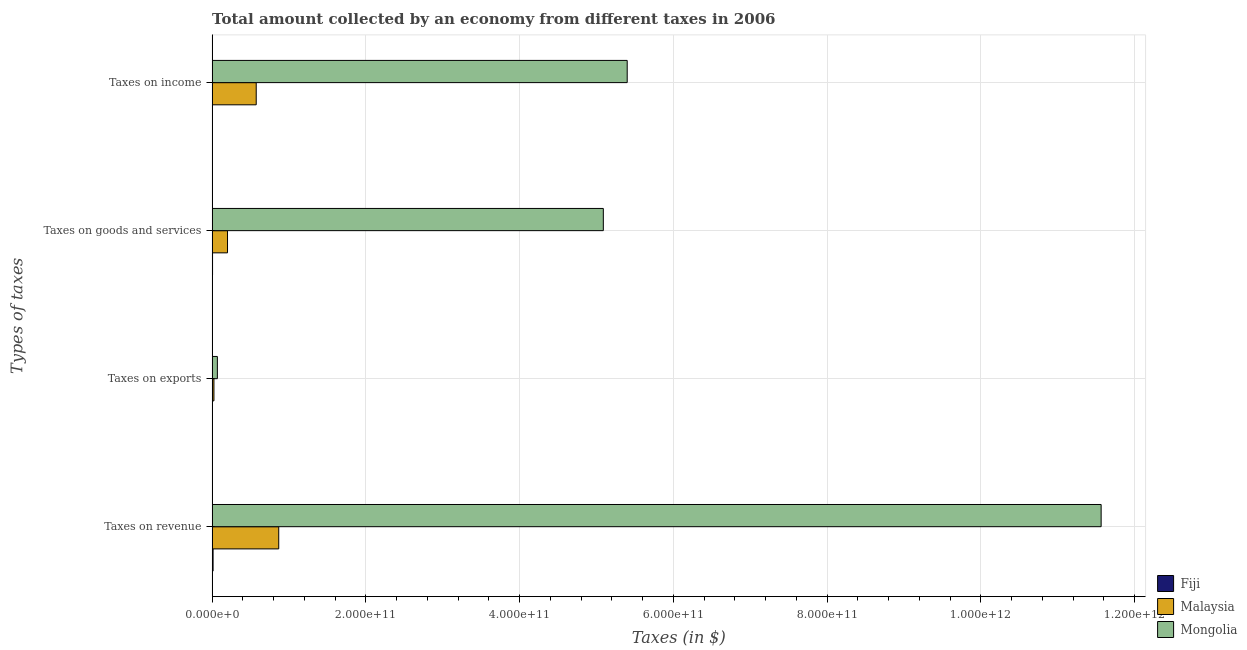How many different coloured bars are there?
Provide a succinct answer. 3. How many bars are there on the 3rd tick from the top?
Make the answer very short. 3. What is the label of the 4th group of bars from the top?
Make the answer very short. Taxes on revenue. What is the amount collected as tax on exports in Malaysia?
Give a very brief answer. 2.36e+09. Across all countries, what is the maximum amount collected as tax on income?
Make the answer very short. 5.40e+11. Across all countries, what is the minimum amount collected as tax on revenue?
Offer a very short reply. 1.25e+09. In which country was the amount collected as tax on exports maximum?
Keep it short and to the point. Mongolia. In which country was the amount collected as tax on income minimum?
Provide a short and direct response. Fiji. What is the total amount collected as tax on exports in the graph?
Your answer should be compact. 9.21e+09. What is the difference between the amount collected as tax on revenue in Mongolia and that in Malaysia?
Provide a short and direct response. 1.07e+12. What is the difference between the amount collected as tax on income in Malaysia and the amount collected as tax on revenue in Fiji?
Offer a very short reply. 5.61e+1. What is the average amount collected as tax on exports per country?
Your response must be concise. 3.07e+09. What is the difference between the amount collected as tax on revenue and amount collected as tax on goods in Malaysia?
Your answer should be very brief. 6.66e+1. In how many countries, is the amount collected as tax on exports greater than 280000000000 $?
Provide a succinct answer. 0. What is the ratio of the amount collected as tax on income in Malaysia to that in Mongolia?
Provide a succinct answer. 0.11. Is the difference between the amount collected as tax on revenue in Mongolia and Malaysia greater than the difference between the amount collected as tax on goods in Mongolia and Malaysia?
Your answer should be very brief. Yes. What is the difference between the highest and the second highest amount collected as tax on exports?
Provide a short and direct response. 4.48e+09. What is the difference between the highest and the lowest amount collected as tax on revenue?
Offer a terse response. 1.16e+12. In how many countries, is the amount collected as tax on income greater than the average amount collected as tax on income taken over all countries?
Offer a very short reply. 1. Is the sum of the amount collected as tax on income in Fiji and Mongolia greater than the maximum amount collected as tax on goods across all countries?
Ensure brevity in your answer.  Yes. Is it the case that in every country, the sum of the amount collected as tax on goods and amount collected as tax on income is greater than the sum of amount collected as tax on exports and amount collected as tax on revenue?
Ensure brevity in your answer.  No. What does the 3rd bar from the top in Taxes on income represents?
Make the answer very short. Fiji. What does the 3rd bar from the bottom in Taxes on goods and services represents?
Provide a succinct answer. Mongolia. Is it the case that in every country, the sum of the amount collected as tax on revenue and amount collected as tax on exports is greater than the amount collected as tax on goods?
Make the answer very short. Yes. How many bars are there?
Your response must be concise. 12. How many countries are there in the graph?
Offer a terse response. 3. What is the difference between two consecutive major ticks on the X-axis?
Offer a terse response. 2.00e+11. Are the values on the major ticks of X-axis written in scientific E-notation?
Ensure brevity in your answer.  Yes. Does the graph contain any zero values?
Provide a short and direct response. No. Does the graph contain grids?
Provide a short and direct response. Yes. What is the title of the graph?
Ensure brevity in your answer.  Total amount collected by an economy from different taxes in 2006. Does "Seychelles" appear as one of the legend labels in the graph?
Ensure brevity in your answer.  No. What is the label or title of the X-axis?
Offer a terse response. Taxes (in $). What is the label or title of the Y-axis?
Give a very brief answer. Types of taxes. What is the Taxes (in $) in Fiji in Taxes on revenue?
Make the answer very short. 1.25e+09. What is the Taxes (in $) in Malaysia in Taxes on revenue?
Make the answer very short. 8.66e+1. What is the Taxes (in $) in Mongolia in Taxes on revenue?
Offer a terse response. 1.16e+12. What is the Taxes (in $) in Fiji in Taxes on exports?
Your answer should be compact. 8.72e+06. What is the Taxes (in $) in Malaysia in Taxes on exports?
Your response must be concise. 2.36e+09. What is the Taxes (in $) of Mongolia in Taxes on exports?
Give a very brief answer. 6.84e+09. What is the Taxes (in $) of Fiji in Taxes on goods and services?
Make the answer very short. 5.62e+08. What is the Taxes (in $) of Malaysia in Taxes on goods and services?
Give a very brief answer. 2.00e+1. What is the Taxes (in $) in Mongolia in Taxes on goods and services?
Give a very brief answer. 5.09e+11. What is the Taxes (in $) of Fiji in Taxes on income?
Your response must be concise. 4.46e+08. What is the Taxes (in $) of Malaysia in Taxes on income?
Give a very brief answer. 5.73e+1. What is the Taxes (in $) of Mongolia in Taxes on income?
Your response must be concise. 5.40e+11. Across all Types of taxes, what is the maximum Taxes (in $) in Fiji?
Your answer should be very brief. 1.25e+09. Across all Types of taxes, what is the maximum Taxes (in $) of Malaysia?
Provide a short and direct response. 8.66e+1. Across all Types of taxes, what is the maximum Taxes (in $) of Mongolia?
Make the answer very short. 1.16e+12. Across all Types of taxes, what is the minimum Taxes (in $) in Fiji?
Your answer should be very brief. 8.72e+06. Across all Types of taxes, what is the minimum Taxes (in $) of Malaysia?
Your answer should be very brief. 2.36e+09. Across all Types of taxes, what is the minimum Taxes (in $) in Mongolia?
Offer a very short reply. 6.84e+09. What is the total Taxes (in $) of Fiji in the graph?
Provide a succinct answer. 2.26e+09. What is the total Taxes (in $) in Malaysia in the graph?
Your answer should be compact. 1.66e+11. What is the total Taxes (in $) of Mongolia in the graph?
Make the answer very short. 2.21e+12. What is the difference between the Taxes (in $) of Fiji in Taxes on revenue and that in Taxes on exports?
Make the answer very short. 1.24e+09. What is the difference between the Taxes (in $) of Malaysia in Taxes on revenue and that in Taxes on exports?
Offer a very short reply. 8.43e+1. What is the difference between the Taxes (in $) in Mongolia in Taxes on revenue and that in Taxes on exports?
Make the answer very short. 1.15e+12. What is the difference between the Taxes (in $) in Fiji in Taxes on revenue and that in Taxes on goods and services?
Make the answer very short. 6.84e+08. What is the difference between the Taxes (in $) in Malaysia in Taxes on revenue and that in Taxes on goods and services?
Provide a short and direct response. 6.66e+1. What is the difference between the Taxes (in $) in Mongolia in Taxes on revenue and that in Taxes on goods and services?
Provide a succinct answer. 6.47e+11. What is the difference between the Taxes (in $) of Fiji in Taxes on revenue and that in Taxes on income?
Provide a succinct answer. 7.99e+08. What is the difference between the Taxes (in $) of Malaysia in Taxes on revenue and that in Taxes on income?
Your answer should be compact. 2.93e+1. What is the difference between the Taxes (in $) of Mongolia in Taxes on revenue and that in Taxes on income?
Ensure brevity in your answer.  6.16e+11. What is the difference between the Taxes (in $) of Fiji in Taxes on exports and that in Taxes on goods and services?
Offer a very short reply. -5.53e+08. What is the difference between the Taxes (in $) in Malaysia in Taxes on exports and that in Taxes on goods and services?
Provide a succinct answer. -1.77e+1. What is the difference between the Taxes (in $) in Mongolia in Taxes on exports and that in Taxes on goods and services?
Keep it short and to the point. -5.02e+11. What is the difference between the Taxes (in $) in Fiji in Taxes on exports and that in Taxes on income?
Offer a very short reply. -4.37e+08. What is the difference between the Taxes (in $) of Malaysia in Taxes on exports and that in Taxes on income?
Make the answer very short. -5.50e+1. What is the difference between the Taxes (in $) of Mongolia in Taxes on exports and that in Taxes on income?
Ensure brevity in your answer.  -5.33e+11. What is the difference between the Taxes (in $) of Fiji in Taxes on goods and services and that in Taxes on income?
Keep it short and to the point. 1.15e+08. What is the difference between the Taxes (in $) in Malaysia in Taxes on goods and services and that in Taxes on income?
Your answer should be very brief. -3.73e+1. What is the difference between the Taxes (in $) of Mongolia in Taxes on goods and services and that in Taxes on income?
Offer a terse response. -3.10e+1. What is the difference between the Taxes (in $) of Fiji in Taxes on revenue and the Taxes (in $) of Malaysia in Taxes on exports?
Give a very brief answer. -1.12e+09. What is the difference between the Taxes (in $) of Fiji in Taxes on revenue and the Taxes (in $) of Mongolia in Taxes on exports?
Keep it short and to the point. -5.59e+09. What is the difference between the Taxes (in $) of Malaysia in Taxes on revenue and the Taxes (in $) of Mongolia in Taxes on exports?
Make the answer very short. 7.98e+1. What is the difference between the Taxes (in $) of Fiji in Taxes on revenue and the Taxes (in $) of Malaysia in Taxes on goods and services?
Provide a short and direct response. -1.88e+1. What is the difference between the Taxes (in $) in Fiji in Taxes on revenue and the Taxes (in $) in Mongolia in Taxes on goods and services?
Your response must be concise. -5.08e+11. What is the difference between the Taxes (in $) of Malaysia in Taxes on revenue and the Taxes (in $) of Mongolia in Taxes on goods and services?
Keep it short and to the point. -4.22e+11. What is the difference between the Taxes (in $) in Fiji in Taxes on revenue and the Taxes (in $) in Malaysia in Taxes on income?
Ensure brevity in your answer.  -5.61e+1. What is the difference between the Taxes (in $) in Fiji in Taxes on revenue and the Taxes (in $) in Mongolia in Taxes on income?
Your answer should be compact. -5.39e+11. What is the difference between the Taxes (in $) of Malaysia in Taxes on revenue and the Taxes (in $) of Mongolia in Taxes on income?
Provide a succinct answer. -4.53e+11. What is the difference between the Taxes (in $) of Fiji in Taxes on exports and the Taxes (in $) of Malaysia in Taxes on goods and services?
Your answer should be compact. -2.00e+1. What is the difference between the Taxes (in $) in Fiji in Taxes on exports and the Taxes (in $) in Mongolia in Taxes on goods and services?
Provide a succinct answer. -5.09e+11. What is the difference between the Taxes (in $) of Malaysia in Taxes on exports and the Taxes (in $) of Mongolia in Taxes on goods and services?
Your answer should be compact. -5.06e+11. What is the difference between the Taxes (in $) of Fiji in Taxes on exports and the Taxes (in $) of Malaysia in Taxes on income?
Keep it short and to the point. -5.73e+1. What is the difference between the Taxes (in $) in Fiji in Taxes on exports and the Taxes (in $) in Mongolia in Taxes on income?
Offer a terse response. -5.40e+11. What is the difference between the Taxes (in $) in Malaysia in Taxes on exports and the Taxes (in $) in Mongolia in Taxes on income?
Your response must be concise. -5.38e+11. What is the difference between the Taxes (in $) of Fiji in Taxes on goods and services and the Taxes (in $) of Malaysia in Taxes on income?
Your response must be concise. -5.68e+1. What is the difference between the Taxes (in $) in Fiji in Taxes on goods and services and the Taxes (in $) in Mongolia in Taxes on income?
Your response must be concise. -5.39e+11. What is the difference between the Taxes (in $) in Malaysia in Taxes on goods and services and the Taxes (in $) in Mongolia in Taxes on income?
Give a very brief answer. -5.20e+11. What is the average Taxes (in $) of Fiji per Types of taxes?
Provide a short and direct response. 5.65e+08. What is the average Taxes (in $) in Malaysia per Types of taxes?
Keep it short and to the point. 4.16e+1. What is the average Taxes (in $) in Mongolia per Types of taxes?
Provide a succinct answer. 5.53e+11. What is the difference between the Taxes (in $) in Fiji and Taxes (in $) in Malaysia in Taxes on revenue?
Your response must be concise. -8.54e+1. What is the difference between the Taxes (in $) in Fiji and Taxes (in $) in Mongolia in Taxes on revenue?
Provide a succinct answer. -1.16e+12. What is the difference between the Taxes (in $) of Malaysia and Taxes (in $) of Mongolia in Taxes on revenue?
Ensure brevity in your answer.  -1.07e+12. What is the difference between the Taxes (in $) in Fiji and Taxes (in $) in Malaysia in Taxes on exports?
Provide a short and direct response. -2.35e+09. What is the difference between the Taxes (in $) of Fiji and Taxes (in $) of Mongolia in Taxes on exports?
Make the answer very short. -6.83e+09. What is the difference between the Taxes (in $) in Malaysia and Taxes (in $) in Mongolia in Taxes on exports?
Ensure brevity in your answer.  -4.48e+09. What is the difference between the Taxes (in $) in Fiji and Taxes (in $) in Malaysia in Taxes on goods and services?
Your response must be concise. -1.95e+1. What is the difference between the Taxes (in $) in Fiji and Taxes (in $) in Mongolia in Taxes on goods and services?
Provide a succinct answer. -5.08e+11. What is the difference between the Taxes (in $) in Malaysia and Taxes (in $) in Mongolia in Taxes on goods and services?
Your answer should be very brief. -4.89e+11. What is the difference between the Taxes (in $) in Fiji and Taxes (in $) in Malaysia in Taxes on income?
Provide a succinct answer. -5.69e+1. What is the difference between the Taxes (in $) in Fiji and Taxes (in $) in Mongolia in Taxes on income?
Provide a succinct answer. -5.39e+11. What is the difference between the Taxes (in $) of Malaysia and Taxes (in $) of Mongolia in Taxes on income?
Give a very brief answer. -4.83e+11. What is the ratio of the Taxes (in $) in Fiji in Taxes on revenue to that in Taxes on exports?
Give a very brief answer. 142.86. What is the ratio of the Taxes (in $) in Malaysia in Taxes on revenue to that in Taxes on exports?
Give a very brief answer. 36.68. What is the ratio of the Taxes (in $) of Mongolia in Taxes on revenue to that in Taxes on exports?
Ensure brevity in your answer.  169.05. What is the ratio of the Taxes (in $) of Fiji in Taxes on revenue to that in Taxes on goods and services?
Make the answer very short. 2.22. What is the ratio of the Taxes (in $) in Malaysia in Taxes on revenue to that in Taxes on goods and services?
Give a very brief answer. 4.33. What is the ratio of the Taxes (in $) in Mongolia in Taxes on revenue to that in Taxes on goods and services?
Offer a very short reply. 2.27. What is the ratio of the Taxes (in $) in Fiji in Taxes on revenue to that in Taxes on income?
Your answer should be very brief. 2.79. What is the ratio of the Taxes (in $) of Malaysia in Taxes on revenue to that in Taxes on income?
Provide a short and direct response. 1.51. What is the ratio of the Taxes (in $) of Mongolia in Taxes on revenue to that in Taxes on income?
Your answer should be compact. 2.14. What is the ratio of the Taxes (in $) of Fiji in Taxes on exports to that in Taxes on goods and services?
Your answer should be compact. 0.02. What is the ratio of the Taxes (in $) in Malaysia in Taxes on exports to that in Taxes on goods and services?
Keep it short and to the point. 0.12. What is the ratio of the Taxes (in $) of Mongolia in Taxes on exports to that in Taxes on goods and services?
Give a very brief answer. 0.01. What is the ratio of the Taxes (in $) in Fiji in Taxes on exports to that in Taxes on income?
Give a very brief answer. 0.02. What is the ratio of the Taxes (in $) in Malaysia in Taxes on exports to that in Taxes on income?
Provide a succinct answer. 0.04. What is the ratio of the Taxes (in $) of Mongolia in Taxes on exports to that in Taxes on income?
Provide a succinct answer. 0.01. What is the ratio of the Taxes (in $) of Fiji in Taxes on goods and services to that in Taxes on income?
Keep it short and to the point. 1.26. What is the ratio of the Taxes (in $) in Malaysia in Taxes on goods and services to that in Taxes on income?
Provide a short and direct response. 0.35. What is the ratio of the Taxes (in $) of Mongolia in Taxes on goods and services to that in Taxes on income?
Your answer should be compact. 0.94. What is the difference between the highest and the second highest Taxes (in $) of Fiji?
Your response must be concise. 6.84e+08. What is the difference between the highest and the second highest Taxes (in $) in Malaysia?
Your answer should be very brief. 2.93e+1. What is the difference between the highest and the second highest Taxes (in $) in Mongolia?
Your answer should be compact. 6.16e+11. What is the difference between the highest and the lowest Taxes (in $) in Fiji?
Offer a terse response. 1.24e+09. What is the difference between the highest and the lowest Taxes (in $) of Malaysia?
Provide a succinct answer. 8.43e+1. What is the difference between the highest and the lowest Taxes (in $) of Mongolia?
Offer a terse response. 1.15e+12. 